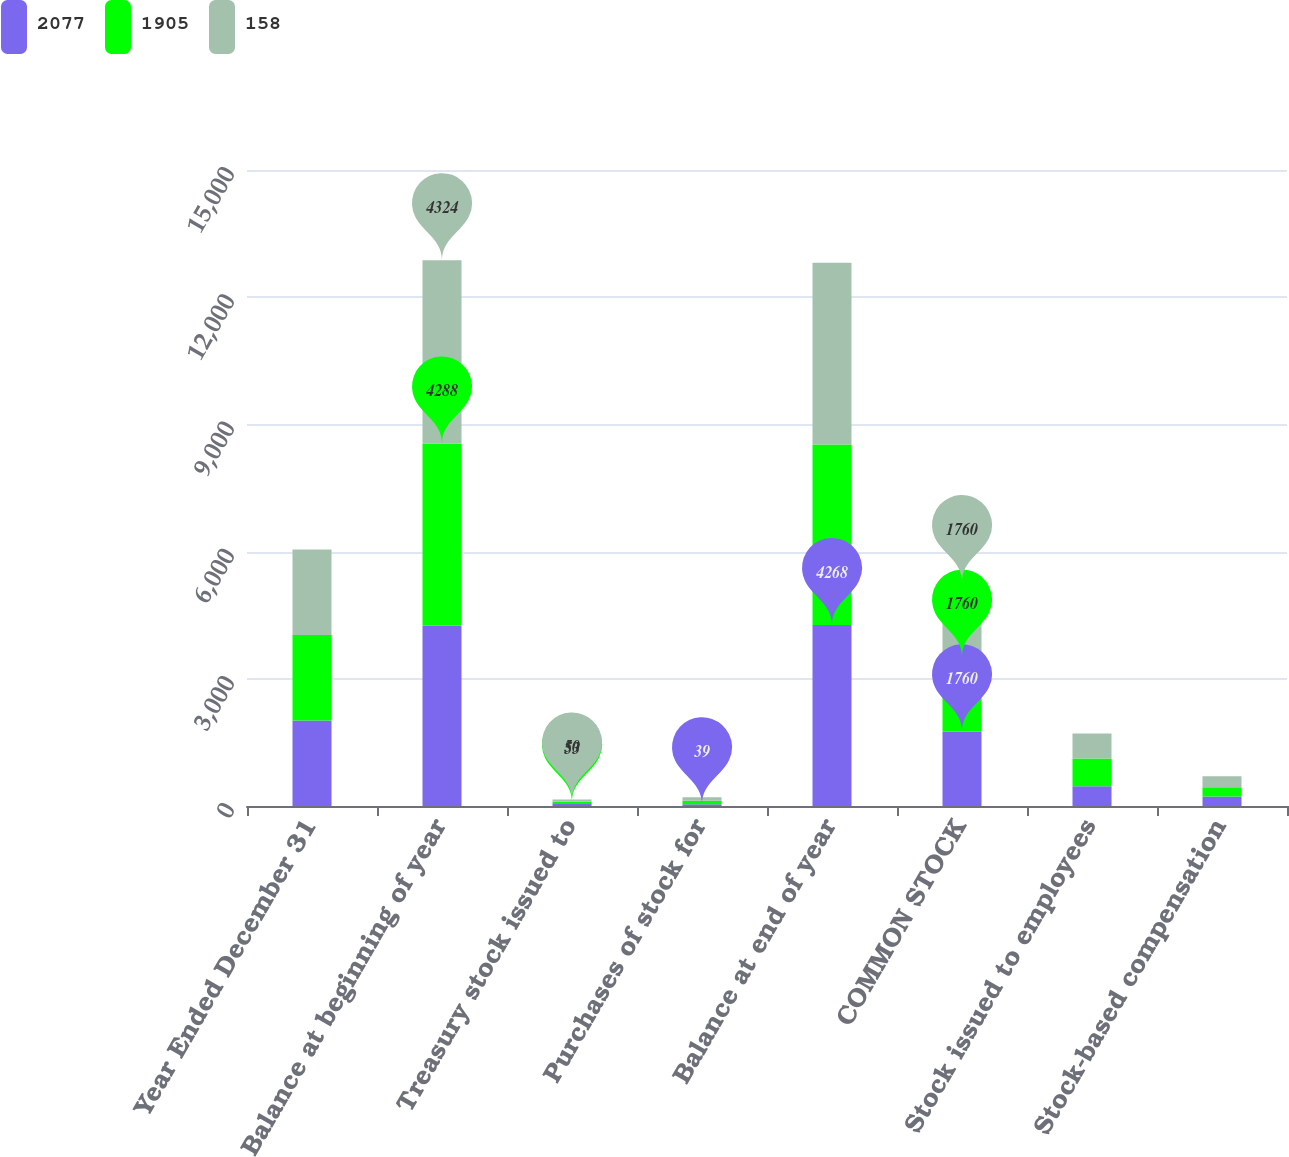<chart> <loc_0><loc_0><loc_500><loc_500><stacked_bar_chart><ecel><fcel>Year Ended December 31<fcel>Balance at beginning of year<fcel>Treasury stock issued to<fcel>Purchases of stock for<fcel>Balance at end of year<fcel>COMMON STOCK<fcel>Stock issued to employees<fcel>Stock-based compensation<nl><fcel>2077<fcel>2018<fcel>4259<fcel>48<fcel>39<fcel>4268<fcel>1760<fcel>467<fcel>225<nl><fcel>1905<fcel>2017<fcel>4288<fcel>53<fcel>82<fcel>4259<fcel>1760<fcel>655<fcel>219<nl><fcel>158<fcel>2016<fcel>4324<fcel>50<fcel>86<fcel>4288<fcel>1760<fcel>589<fcel>258<nl></chart> 